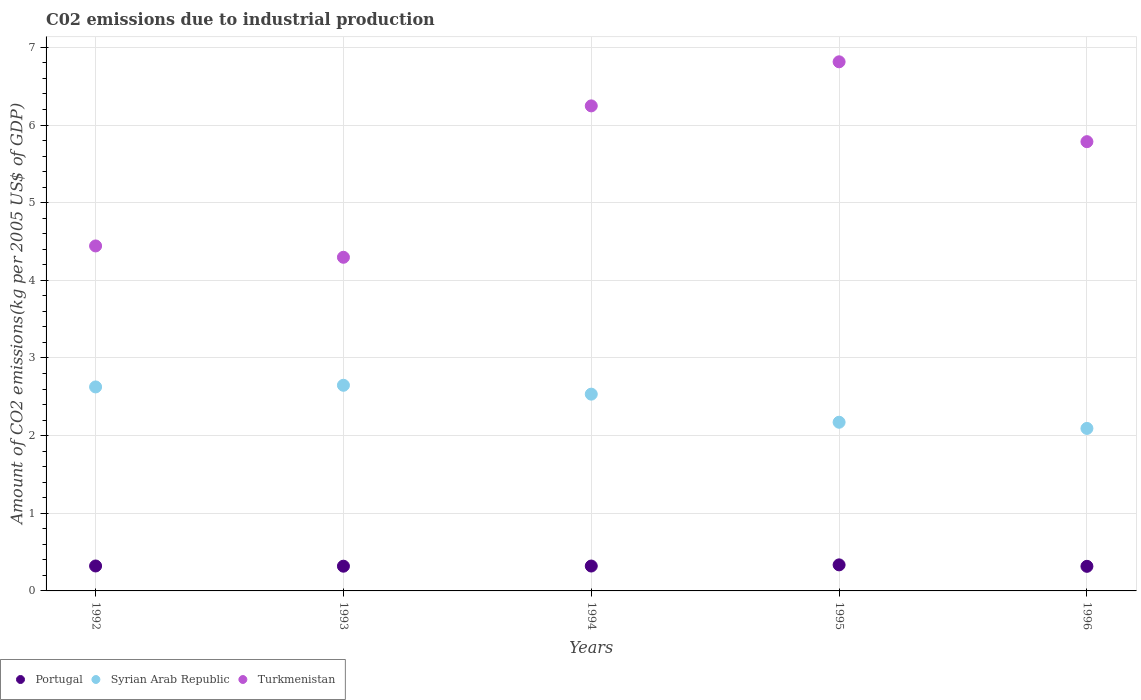How many different coloured dotlines are there?
Offer a very short reply. 3. What is the amount of CO2 emitted due to industrial production in Turkmenistan in 1992?
Offer a very short reply. 4.44. Across all years, what is the maximum amount of CO2 emitted due to industrial production in Syrian Arab Republic?
Make the answer very short. 2.65. Across all years, what is the minimum amount of CO2 emitted due to industrial production in Portugal?
Provide a succinct answer. 0.32. In which year was the amount of CO2 emitted due to industrial production in Syrian Arab Republic maximum?
Your answer should be very brief. 1993. In which year was the amount of CO2 emitted due to industrial production in Portugal minimum?
Your answer should be compact. 1996. What is the total amount of CO2 emitted due to industrial production in Portugal in the graph?
Ensure brevity in your answer.  1.61. What is the difference between the amount of CO2 emitted due to industrial production in Syrian Arab Republic in 1993 and that in 1995?
Your response must be concise. 0.48. What is the difference between the amount of CO2 emitted due to industrial production in Syrian Arab Republic in 1992 and the amount of CO2 emitted due to industrial production in Turkmenistan in 1996?
Keep it short and to the point. -3.16. What is the average amount of CO2 emitted due to industrial production in Syrian Arab Republic per year?
Provide a succinct answer. 2.41. In the year 1993, what is the difference between the amount of CO2 emitted due to industrial production in Turkmenistan and amount of CO2 emitted due to industrial production in Portugal?
Give a very brief answer. 3.98. In how many years, is the amount of CO2 emitted due to industrial production in Portugal greater than 1.2 kg?
Make the answer very short. 0. What is the ratio of the amount of CO2 emitted due to industrial production in Portugal in 1994 to that in 1996?
Offer a very short reply. 1.01. Is the difference between the amount of CO2 emitted due to industrial production in Turkmenistan in 1992 and 1994 greater than the difference between the amount of CO2 emitted due to industrial production in Portugal in 1992 and 1994?
Ensure brevity in your answer.  No. What is the difference between the highest and the second highest amount of CO2 emitted due to industrial production in Syrian Arab Republic?
Provide a short and direct response. 0.02. What is the difference between the highest and the lowest amount of CO2 emitted due to industrial production in Syrian Arab Republic?
Make the answer very short. 0.56. In how many years, is the amount of CO2 emitted due to industrial production in Turkmenistan greater than the average amount of CO2 emitted due to industrial production in Turkmenistan taken over all years?
Provide a succinct answer. 3. Is the sum of the amount of CO2 emitted due to industrial production in Syrian Arab Republic in 1992 and 1995 greater than the maximum amount of CO2 emitted due to industrial production in Turkmenistan across all years?
Offer a terse response. No. Does the amount of CO2 emitted due to industrial production in Syrian Arab Republic monotonically increase over the years?
Keep it short and to the point. No. How many dotlines are there?
Make the answer very short. 3. How many years are there in the graph?
Provide a short and direct response. 5. Are the values on the major ticks of Y-axis written in scientific E-notation?
Ensure brevity in your answer.  No. Does the graph contain any zero values?
Offer a terse response. No. Does the graph contain grids?
Keep it short and to the point. Yes. How many legend labels are there?
Keep it short and to the point. 3. How are the legend labels stacked?
Your answer should be compact. Horizontal. What is the title of the graph?
Make the answer very short. C02 emissions due to industrial production. What is the label or title of the X-axis?
Your answer should be very brief. Years. What is the label or title of the Y-axis?
Give a very brief answer. Amount of CO2 emissions(kg per 2005 US$ of GDP). What is the Amount of CO2 emissions(kg per 2005 US$ of GDP) of Portugal in 1992?
Provide a succinct answer. 0.32. What is the Amount of CO2 emissions(kg per 2005 US$ of GDP) in Syrian Arab Republic in 1992?
Offer a very short reply. 2.63. What is the Amount of CO2 emissions(kg per 2005 US$ of GDP) in Turkmenistan in 1992?
Give a very brief answer. 4.44. What is the Amount of CO2 emissions(kg per 2005 US$ of GDP) of Portugal in 1993?
Provide a succinct answer. 0.32. What is the Amount of CO2 emissions(kg per 2005 US$ of GDP) in Syrian Arab Republic in 1993?
Give a very brief answer. 2.65. What is the Amount of CO2 emissions(kg per 2005 US$ of GDP) in Turkmenistan in 1993?
Your response must be concise. 4.3. What is the Amount of CO2 emissions(kg per 2005 US$ of GDP) of Portugal in 1994?
Your response must be concise. 0.32. What is the Amount of CO2 emissions(kg per 2005 US$ of GDP) in Syrian Arab Republic in 1994?
Your response must be concise. 2.53. What is the Amount of CO2 emissions(kg per 2005 US$ of GDP) of Turkmenistan in 1994?
Make the answer very short. 6.25. What is the Amount of CO2 emissions(kg per 2005 US$ of GDP) of Portugal in 1995?
Your response must be concise. 0.34. What is the Amount of CO2 emissions(kg per 2005 US$ of GDP) in Syrian Arab Republic in 1995?
Your answer should be very brief. 2.17. What is the Amount of CO2 emissions(kg per 2005 US$ of GDP) of Turkmenistan in 1995?
Give a very brief answer. 6.81. What is the Amount of CO2 emissions(kg per 2005 US$ of GDP) of Portugal in 1996?
Offer a very short reply. 0.32. What is the Amount of CO2 emissions(kg per 2005 US$ of GDP) of Syrian Arab Republic in 1996?
Ensure brevity in your answer.  2.09. What is the Amount of CO2 emissions(kg per 2005 US$ of GDP) of Turkmenistan in 1996?
Your response must be concise. 5.79. Across all years, what is the maximum Amount of CO2 emissions(kg per 2005 US$ of GDP) of Portugal?
Make the answer very short. 0.34. Across all years, what is the maximum Amount of CO2 emissions(kg per 2005 US$ of GDP) of Syrian Arab Republic?
Give a very brief answer. 2.65. Across all years, what is the maximum Amount of CO2 emissions(kg per 2005 US$ of GDP) of Turkmenistan?
Your answer should be very brief. 6.81. Across all years, what is the minimum Amount of CO2 emissions(kg per 2005 US$ of GDP) of Portugal?
Offer a very short reply. 0.32. Across all years, what is the minimum Amount of CO2 emissions(kg per 2005 US$ of GDP) in Syrian Arab Republic?
Make the answer very short. 2.09. Across all years, what is the minimum Amount of CO2 emissions(kg per 2005 US$ of GDP) of Turkmenistan?
Give a very brief answer. 4.3. What is the total Amount of CO2 emissions(kg per 2005 US$ of GDP) of Portugal in the graph?
Provide a short and direct response. 1.61. What is the total Amount of CO2 emissions(kg per 2005 US$ of GDP) in Syrian Arab Republic in the graph?
Ensure brevity in your answer.  12.07. What is the total Amount of CO2 emissions(kg per 2005 US$ of GDP) of Turkmenistan in the graph?
Your answer should be compact. 27.59. What is the difference between the Amount of CO2 emissions(kg per 2005 US$ of GDP) of Portugal in 1992 and that in 1993?
Provide a succinct answer. 0. What is the difference between the Amount of CO2 emissions(kg per 2005 US$ of GDP) in Syrian Arab Republic in 1992 and that in 1993?
Provide a short and direct response. -0.02. What is the difference between the Amount of CO2 emissions(kg per 2005 US$ of GDP) in Turkmenistan in 1992 and that in 1993?
Give a very brief answer. 0.15. What is the difference between the Amount of CO2 emissions(kg per 2005 US$ of GDP) of Portugal in 1992 and that in 1994?
Keep it short and to the point. 0. What is the difference between the Amount of CO2 emissions(kg per 2005 US$ of GDP) of Syrian Arab Republic in 1992 and that in 1994?
Offer a very short reply. 0.09. What is the difference between the Amount of CO2 emissions(kg per 2005 US$ of GDP) of Turkmenistan in 1992 and that in 1994?
Give a very brief answer. -1.8. What is the difference between the Amount of CO2 emissions(kg per 2005 US$ of GDP) in Portugal in 1992 and that in 1995?
Keep it short and to the point. -0.01. What is the difference between the Amount of CO2 emissions(kg per 2005 US$ of GDP) of Syrian Arab Republic in 1992 and that in 1995?
Keep it short and to the point. 0.45. What is the difference between the Amount of CO2 emissions(kg per 2005 US$ of GDP) of Turkmenistan in 1992 and that in 1995?
Ensure brevity in your answer.  -2.37. What is the difference between the Amount of CO2 emissions(kg per 2005 US$ of GDP) in Portugal in 1992 and that in 1996?
Offer a very short reply. 0. What is the difference between the Amount of CO2 emissions(kg per 2005 US$ of GDP) of Syrian Arab Republic in 1992 and that in 1996?
Make the answer very short. 0.53. What is the difference between the Amount of CO2 emissions(kg per 2005 US$ of GDP) in Turkmenistan in 1992 and that in 1996?
Make the answer very short. -1.34. What is the difference between the Amount of CO2 emissions(kg per 2005 US$ of GDP) of Portugal in 1993 and that in 1994?
Your answer should be compact. -0. What is the difference between the Amount of CO2 emissions(kg per 2005 US$ of GDP) in Syrian Arab Republic in 1993 and that in 1994?
Give a very brief answer. 0.11. What is the difference between the Amount of CO2 emissions(kg per 2005 US$ of GDP) of Turkmenistan in 1993 and that in 1994?
Provide a succinct answer. -1.95. What is the difference between the Amount of CO2 emissions(kg per 2005 US$ of GDP) in Portugal in 1993 and that in 1995?
Ensure brevity in your answer.  -0.02. What is the difference between the Amount of CO2 emissions(kg per 2005 US$ of GDP) in Syrian Arab Republic in 1993 and that in 1995?
Your answer should be very brief. 0.48. What is the difference between the Amount of CO2 emissions(kg per 2005 US$ of GDP) of Turkmenistan in 1993 and that in 1995?
Keep it short and to the point. -2.52. What is the difference between the Amount of CO2 emissions(kg per 2005 US$ of GDP) of Portugal in 1993 and that in 1996?
Your answer should be very brief. 0. What is the difference between the Amount of CO2 emissions(kg per 2005 US$ of GDP) of Syrian Arab Republic in 1993 and that in 1996?
Offer a very short reply. 0.56. What is the difference between the Amount of CO2 emissions(kg per 2005 US$ of GDP) in Turkmenistan in 1993 and that in 1996?
Offer a very short reply. -1.49. What is the difference between the Amount of CO2 emissions(kg per 2005 US$ of GDP) of Portugal in 1994 and that in 1995?
Offer a very short reply. -0.01. What is the difference between the Amount of CO2 emissions(kg per 2005 US$ of GDP) of Syrian Arab Republic in 1994 and that in 1995?
Keep it short and to the point. 0.36. What is the difference between the Amount of CO2 emissions(kg per 2005 US$ of GDP) of Turkmenistan in 1994 and that in 1995?
Make the answer very short. -0.57. What is the difference between the Amount of CO2 emissions(kg per 2005 US$ of GDP) in Portugal in 1994 and that in 1996?
Your answer should be compact. 0. What is the difference between the Amount of CO2 emissions(kg per 2005 US$ of GDP) in Syrian Arab Republic in 1994 and that in 1996?
Your response must be concise. 0.44. What is the difference between the Amount of CO2 emissions(kg per 2005 US$ of GDP) in Turkmenistan in 1994 and that in 1996?
Your response must be concise. 0.46. What is the difference between the Amount of CO2 emissions(kg per 2005 US$ of GDP) of Portugal in 1995 and that in 1996?
Keep it short and to the point. 0.02. What is the difference between the Amount of CO2 emissions(kg per 2005 US$ of GDP) of Syrian Arab Republic in 1995 and that in 1996?
Make the answer very short. 0.08. What is the difference between the Amount of CO2 emissions(kg per 2005 US$ of GDP) in Turkmenistan in 1995 and that in 1996?
Make the answer very short. 1.03. What is the difference between the Amount of CO2 emissions(kg per 2005 US$ of GDP) of Portugal in 1992 and the Amount of CO2 emissions(kg per 2005 US$ of GDP) of Syrian Arab Republic in 1993?
Provide a succinct answer. -2.33. What is the difference between the Amount of CO2 emissions(kg per 2005 US$ of GDP) in Portugal in 1992 and the Amount of CO2 emissions(kg per 2005 US$ of GDP) in Turkmenistan in 1993?
Your response must be concise. -3.98. What is the difference between the Amount of CO2 emissions(kg per 2005 US$ of GDP) of Syrian Arab Republic in 1992 and the Amount of CO2 emissions(kg per 2005 US$ of GDP) of Turkmenistan in 1993?
Provide a succinct answer. -1.67. What is the difference between the Amount of CO2 emissions(kg per 2005 US$ of GDP) in Portugal in 1992 and the Amount of CO2 emissions(kg per 2005 US$ of GDP) in Syrian Arab Republic in 1994?
Provide a succinct answer. -2.21. What is the difference between the Amount of CO2 emissions(kg per 2005 US$ of GDP) in Portugal in 1992 and the Amount of CO2 emissions(kg per 2005 US$ of GDP) in Turkmenistan in 1994?
Offer a very short reply. -5.93. What is the difference between the Amount of CO2 emissions(kg per 2005 US$ of GDP) of Syrian Arab Republic in 1992 and the Amount of CO2 emissions(kg per 2005 US$ of GDP) of Turkmenistan in 1994?
Keep it short and to the point. -3.62. What is the difference between the Amount of CO2 emissions(kg per 2005 US$ of GDP) of Portugal in 1992 and the Amount of CO2 emissions(kg per 2005 US$ of GDP) of Syrian Arab Republic in 1995?
Your answer should be compact. -1.85. What is the difference between the Amount of CO2 emissions(kg per 2005 US$ of GDP) in Portugal in 1992 and the Amount of CO2 emissions(kg per 2005 US$ of GDP) in Turkmenistan in 1995?
Offer a very short reply. -6.49. What is the difference between the Amount of CO2 emissions(kg per 2005 US$ of GDP) of Syrian Arab Republic in 1992 and the Amount of CO2 emissions(kg per 2005 US$ of GDP) of Turkmenistan in 1995?
Your answer should be very brief. -4.19. What is the difference between the Amount of CO2 emissions(kg per 2005 US$ of GDP) in Portugal in 1992 and the Amount of CO2 emissions(kg per 2005 US$ of GDP) in Syrian Arab Republic in 1996?
Give a very brief answer. -1.77. What is the difference between the Amount of CO2 emissions(kg per 2005 US$ of GDP) of Portugal in 1992 and the Amount of CO2 emissions(kg per 2005 US$ of GDP) of Turkmenistan in 1996?
Provide a succinct answer. -5.46. What is the difference between the Amount of CO2 emissions(kg per 2005 US$ of GDP) of Syrian Arab Republic in 1992 and the Amount of CO2 emissions(kg per 2005 US$ of GDP) of Turkmenistan in 1996?
Offer a very short reply. -3.16. What is the difference between the Amount of CO2 emissions(kg per 2005 US$ of GDP) of Portugal in 1993 and the Amount of CO2 emissions(kg per 2005 US$ of GDP) of Syrian Arab Republic in 1994?
Give a very brief answer. -2.22. What is the difference between the Amount of CO2 emissions(kg per 2005 US$ of GDP) of Portugal in 1993 and the Amount of CO2 emissions(kg per 2005 US$ of GDP) of Turkmenistan in 1994?
Give a very brief answer. -5.93. What is the difference between the Amount of CO2 emissions(kg per 2005 US$ of GDP) of Syrian Arab Republic in 1993 and the Amount of CO2 emissions(kg per 2005 US$ of GDP) of Turkmenistan in 1994?
Offer a very short reply. -3.6. What is the difference between the Amount of CO2 emissions(kg per 2005 US$ of GDP) of Portugal in 1993 and the Amount of CO2 emissions(kg per 2005 US$ of GDP) of Syrian Arab Republic in 1995?
Offer a very short reply. -1.85. What is the difference between the Amount of CO2 emissions(kg per 2005 US$ of GDP) of Portugal in 1993 and the Amount of CO2 emissions(kg per 2005 US$ of GDP) of Turkmenistan in 1995?
Ensure brevity in your answer.  -6.5. What is the difference between the Amount of CO2 emissions(kg per 2005 US$ of GDP) in Syrian Arab Republic in 1993 and the Amount of CO2 emissions(kg per 2005 US$ of GDP) in Turkmenistan in 1995?
Your response must be concise. -4.17. What is the difference between the Amount of CO2 emissions(kg per 2005 US$ of GDP) of Portugal in 1993 and the Amount of CO2 emissions(kg per 2005 US$ of GDP) of Syrian Arab Republic in 1996?
Provide a succinct answer. -1.77. What is the difference between the Amount of CO2 emissions(kg per 2005 US$ of GDP) in Portugal in 1993 and the Amount of CO2 emissions(kg per 2005 US$ of GDP) in Turkmenistan in 1996?
Make the answer very short. -5.47. What is the difference between the Amount of CO2 emissions(kg per 2005 US$ of GDP) of Syrian Arab Republic in 1993 and the Amount of CO2 emissions(kg per 2005 US$ of GDP) of Turkmenistan in 1996?
Give a very brief answer. -3.14. What is the difference between the Amount of CO2 emissions(kg per 2005 US$ of GDP) of Portugal in 1994 and the Amount of CO2 emissions(kg per 2005 US$ of GDP) of Syrian Arab Republic in 1995?
Offer a very short reply. -1.85. What is the difference between the Amount of CO2 emissions(kg per 2005 US$ of GDP) in Portugal in 1994 and the Amount of CO2 emissions(kg per 2005 US$ of GDP) in Turkmenistan in 1995?
Your answer should be compact. -6.49. What is the difference between the Amount of CO2 emissions(kg per 2005 US$ of GDP) in Syrian Arab Republic in 1994 and the Amount of CO2 emissions(kg per 2005 US$ of GDP) in Turkmenistan in 1995?
Make the answer very short. -4.28. What is the difference between the Amount of CO2 emissions(kg per 2005 US$ of GDP) in Portugal in 1994 and the Amount of CO2 emissions(kg per 2005 US$ of GDP) in Syrian Arab Republic in 1996?
Your answer should be very brief. -1.77. What is the difference between the Amount of CO2 emissions(kg per 2005 US$ of GDP) of Portugal in 1994 and the Amount of CO2 emissions(kg per 2005 US$ of GDP) of Turkmenistan in 1996?
Your response must be concise. -5.47. What is the difference between the Amount of CO2 emissions(kg per 2005 US$ of GDP) in Syrian Arab Republic in 1994 and the Amount of CO2 emissions(kg per 2005 US$ of GDP) in Turkmenistan in 1996?
Keep it short and to the point. -3.25. What is the difference between the Amount of CO2 emissions(kg per 2005 US$ of GDP) of Portugal in 1995 and the Amount of CO2 emissions(kg per 2005 US$ of GDP) of Syrian Arab Republic in 1996?
Your answer should be compact. -1.76. What is the difference between the Amount of CO2 emissions(kg per 2005 US$ of GDP) in Portugal in 1995 and the Amount of CO2 emissions(kg per 2005 US$ of GDP) in Turkmenistan in 1996?
Provide a short and direct response. -5.45. What is the difference between the Amount of CO2 emissions(kg per 2005 US$ of GDP) in Syrian Arab Republic in 1995 and the Amount of CO2 emissions(kg per 2005 US$ of GDP) in Turkmenistan in 1996?
Provide a short and direct response. -3.61. What is the average Amount of CO2 emissions(kg per 2005 US$ of GDP) of Portugal per year?
Keep it short and to the point. 0.32. What is the average Amount of CO2 emissions(kg per 2005 US$ of GDP) of Syrian Arab Republic per year?
Your answer should be very brief. 2.42. What is the average Amount of CO2 emissions(kg per 2005 US$ of GDP) of Turkmenistan per year?
Offer a terse response. 5.52. In the year 1992, what is the difference between the Amount of CO2 emissions(kg per 2005 US$ of GDP) in Portugal and Amount of CO2 emissions(kg per 2005 US$ of GDP) in Syrian Arab Republic?
Offer a very short reply. -2.31. In the year 1992, what is the difference between the Amount of CO2 emissions(kg per 2005 US$ of GDP) of Portugal and Amount of CO2 emissions(kg per 2005 US$ of GDP) of Turkmenistan?
Keep it short and to the point. -4.12. In the year 1992, what is the difference between the Amount of CO2 emissions(kg per 2005 US$ of GDP) in Syrian Arab Republic and Amount of CO2 emissions(kg per 2005 US$ of GDP) in Turkmenistan?
Your response must be concise. -1.82. In the year 1993, what is the difference between the Amount of CO2 emissions(kg per 2005 US$ of GDP) in Portugal and Amount of CO2 emissions(kg per 2005 US$ of GDP) in Syrian Arab Republic?
Provide a succinct answer. -2.33. In the year 1993, what is the difference between the Amount of CO2 emissions(kg per 2005 US$ of GDP) of Portugal and Amount of CO2 emissions(kg per 2005 US$ of GDP) of Turkmenistan?
Your response must be concise. -3.98. In the year 1993, what is the difference between the Amount of CO2 emissions(kg per 2005 US$ of GDP) in Syrian Arab Republic and Amount of CO2 emissions(kg per 2005 US$ of GDP) in Turkmenistan?
Offer a terse response. -1.65. In the year 1994, what is the difference between the Amount of CO2 emissions(kg per 2005 US$ of GDP) of Portugal and Amount of CO2 emissions(kg per 2005 US$ of GDP) of Syrian Arab Republic?
Make the answer very short. -2.21. In the year 1994, what is the difference between the Amount of CO2 emissions(kg per 2005 US$ of GDP) of Portugal and Amount of CO2 emissions(kg per 2005 US$ of GDP) of Turkmenistan?
Provide a succinct answer. -5.93. In the year 1994, what is the difference between the Amount of CO2 emissions(kg per 2005 US$ of GDP) in Syrian Arab Republic and Amount of CO2 emissions(kg per 2005 US$ of GDP) in Turkmenistan?
Your response must be concise. -3.71. In the year 1995, what is the difference between the Amount of CO2 emissions(kg per 2005 US$ of GDP) in Portugal and Amount of CO2 emissions(kg per 2005 US$ of GDP) in Syrian Arab Republic?
Keep it short and to the point. -1.84. In the year 1995, what is the difference between the Amount of CO2 emissions(kg per 2005 US$ of GDP) in Portugal and Amount of CO2 emissions(kg per 2005 US$ of GDP) in Turkmenistan?
Provide a short and direct response. -6.48. In the year 1995, what is the difference between the Amount of CO2 emissions(kg per 2005 US$ of GDP) in Syrian Arab Republic and Amount of CO2 emissions(kg per 2005 US$ of GDP) in Turkmenistan?
Make the answer very short. -4.64. In the year 1996, what is the difference between the Amount of CO2 emissions(kg per 2005 US$ of GDP) of Portugal and Amount of CO2 emissions(kg per 2005 US$ of GDP) of Syrian Arab Republic?
Ensure brevity in your answer.  -1.78. In the year 1996, what is the difference between the Amount of CO2 emissions(kg per 2005 US$ of GDP) in Portugal and Amount of CO2 emissions(kg per 2005 US$ of GDP) in Turkmenistan?
Your answer should be very brief. -5.47. In the year 1996, what is the difference between the Amount of CO2 emissions(kg per 2005 US$ of GDP) of Syrian Arab Republic and Amount of CO2 emissions(kg per 2005 US$ of GDP) of Turkmenistan?
Keep it short and to the point. -3.69. What is the ratio of the Amount of CO2 emissions(kg per 2005 US$ of GDP) of Portugal in 1992 to that in 1993?
Keep it short and to the point. 1.01. What is the ratio of the Amount of CO2 emissions(kg per 2005 US$ of GDP) of Turkmenistan in 1992 to that in 1993?
Ensure brevity in your answer.  1.03. What is the ratio of the Amount of CO2 emissions(kg per 2005 US$ of GDP) in Portugal in 1992 to that in 1994?
Your answer should be very brief. 1. What is the ratio of the Amount of CO2 emissions(kg per 2005 US$ of GDP) of Syrian Arab Republic in 1992 to that in 1994?
Keep it short and to the point. 1.04. What is the ratio of the Amount of CO2 emissions(kg per 2005 US$ of GDP) of Turkmenistan in 1992 to that in 1994?
Offer a terse response. 0.71. What is the ratio of the Amount of CO2 emissions(kg per 2005 US$ of GDP) of Portugal in 1992 to that in 1995?
Give a very brief answer. 0.96. What is the ratio of the Amount of CO2 emissions(kg per 2005 US$ of GDP) of Syrian Arab Republic in 1992 to that in 1995?
Provide a succinct answer. 1.21. What is the ratio of the Amount of CO2 emissions(kg per 2005 US$ of GDP) in Turkmenistan in 1992 to that in 1995?
Your response must be concise. 0.65. What is the ratio of the Amount of CO2 emissions(kg per 2005 US$ of GDP) in Syrian Arab Republic in 1992 to that in 1996?
Ensure brevity in your answer.  1.26. What is the ratio of the Amount of CO2 emissions(kg per 2005 US$ of GDP) of Turkmenistan in 1992 to that in 1996?
Ensure brevity in your answer.  0.77. What is the ratio of the Amount of CO2 emissions(kg per 2005 US$ of GDP) in Syrian Arab Republic in 1993 to that in 1994?
Make the answer very short. 1.05. What is the ratio of the Amount of CO2 emissions(kg per 2005 US$ of GDP) in Turkmenistan in 1993 to that in 1994?
Make the answer very short. 0.69. What is the ratio of the Amount of CO2 emissions(kg per 2005 US$ of GDP) in Portugal in 1993 to that in 1995?
Keep it short and to the point. 0.95. What is the ratio of the Amount of CO2 emissions(kg per 2005 US$ of GDP) in Syrian Arab Republic in 1993 to that in 1995?
Your response must be concise. 1.22. What is the ratio of the Amount of CO2 emissions(kg per 2005 US$ of GDP) of Turkmenistan in 1993 to that in 1995?
Offer a terse response. 0.63. What is the ratio of the Amount of CO2 emissions(kg per 2005 US$ of GDP) of Portugal in 1993 to that in 1996?
Give a very brief answer. 1.01. What is the ratio of the Amount of CO2 emissions(kg per 2005 US$ of GDP) in Syrian Arab Republic in 1993 to that in 1996?
Provide a short and direct response. 1.27. What is the ratio of the Amount of CO2 emissions(kg per 2005 US$ of GDP) of Turkmenistan in 1993 to that in 1996?
Provide a succinct answer. 0.74. What is the ratio of the Amount of CO2 emissions(kg per 2005 US$ of GDP) in Portugal in 1994 to that in 1995?
Your answer should be very brief. 0.96. What is the ratio of the Amount of CO2 emissions(kg per 2005 US$ of GDP) in Syrian Arab Republic in 1994 to that in 1995?
Your answer should be compact. 1.17. What is the ratio of the Amount of CO2 emissions(kg per 2005 US$ of GDP) in Turkmenistan in 1994 to that in 1995?
Your answer should be very brief. 0.92. What is the ratio of the Amount of CO2 emissions(kg per 2005 US$ of GDP) of Portugal in 1994 to that in 1996?
Your answer should be compact. 1.01. What is the ratio of the Amount of CO2 emissions(kg per 2005 US$ of GDP) in Syrian Arab Republic in 1994 to that in 1996?
Make the answer very short. 1.21. What is the ratio of the Amount of CO2 emissions(kg per 2005 US$ of GDP) in Turkmenistan in 1994 to that in 1996?
Offer a very short reply. 1.08. What is the ratio of the Amount of CO2 emissions(kg per 2005 US$ of GDP) of Portugal in 1995 to that in 1996?
Make the answer very short. 1.06. What is the ratio of the Amount of CO2 emissions(kg per 2005 US$ of GDP) of Syrian Arab Republic in 1995 to that in 1996?
Keep it short and to the point. 1.04. What is the ratio of the Amount of CO2 emissions(kg per 2005 US$ of GDP) of Turkmenistan in 1995 to that in 1996?
Provide a succinct answer. 1.18. What is the difference between the highest and the second highest Amount of CO2 emissions(kg per 2005 US$ of GDP) in Portugal?
Keep it short and to the point. 0.01. What is the difference between the highest and the second highest Amount of CO2 emissions(kg per 2005 US$ of GDP) of Syrian Arab Republic?
Offer a very short reply. 0.02. What is the difference between the highest and the second highest Amount of CO2 emissions(kg per 2005 US$ of GDP) of Turkmenistan?
Give a very brief answer. 0.57. What is the difference between the highest and the lowest Amount of CO2 emissions(kg per 2005 US$ of GDP) in Portugal?
Offer a terse response. 0.02. What is the difference between the highest and the lowest Amount of CO2 emissions(kg per 2005 US$ of GDP) in Syrian Arab Republic?
Your answer should be very brief. 0.56. What is the difference between the highest and the lowest Amount of CO2 emissions(kg per 2005 US$ of GDP) of Turkmenistan?
Your answer should be compact. 2.52. 